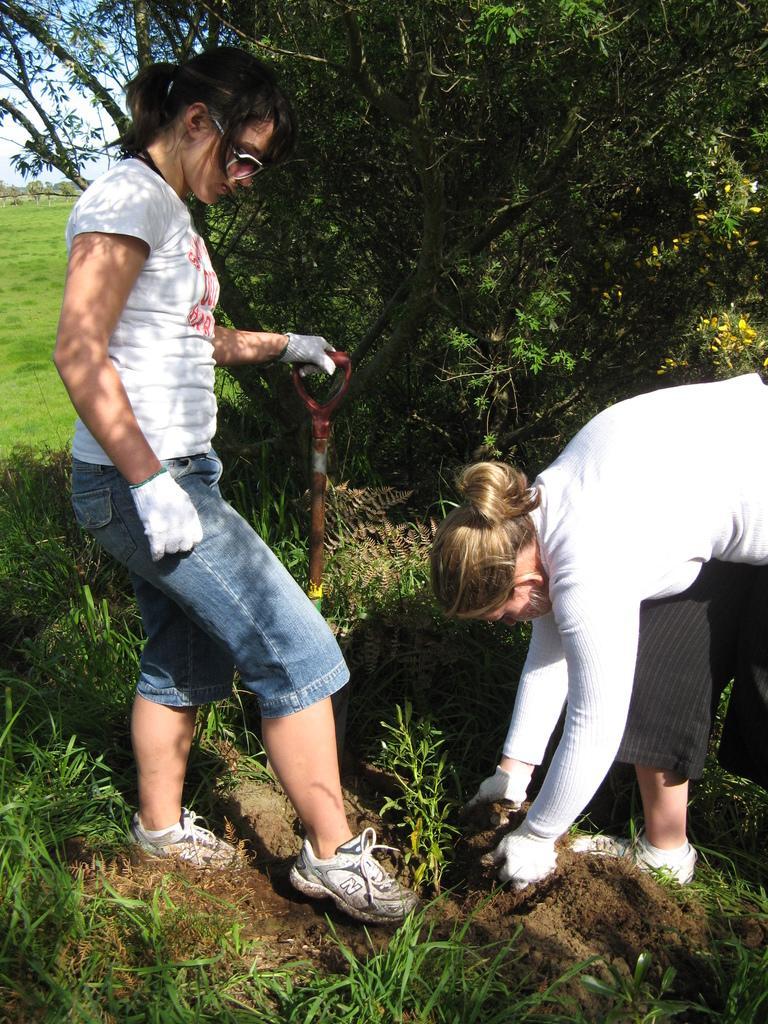In one or two sentences, can you explain what this image depicts? In this picture there are two girls on the right and left side of the image, it seems to be they are digging and there is greenery around the area of the image. 